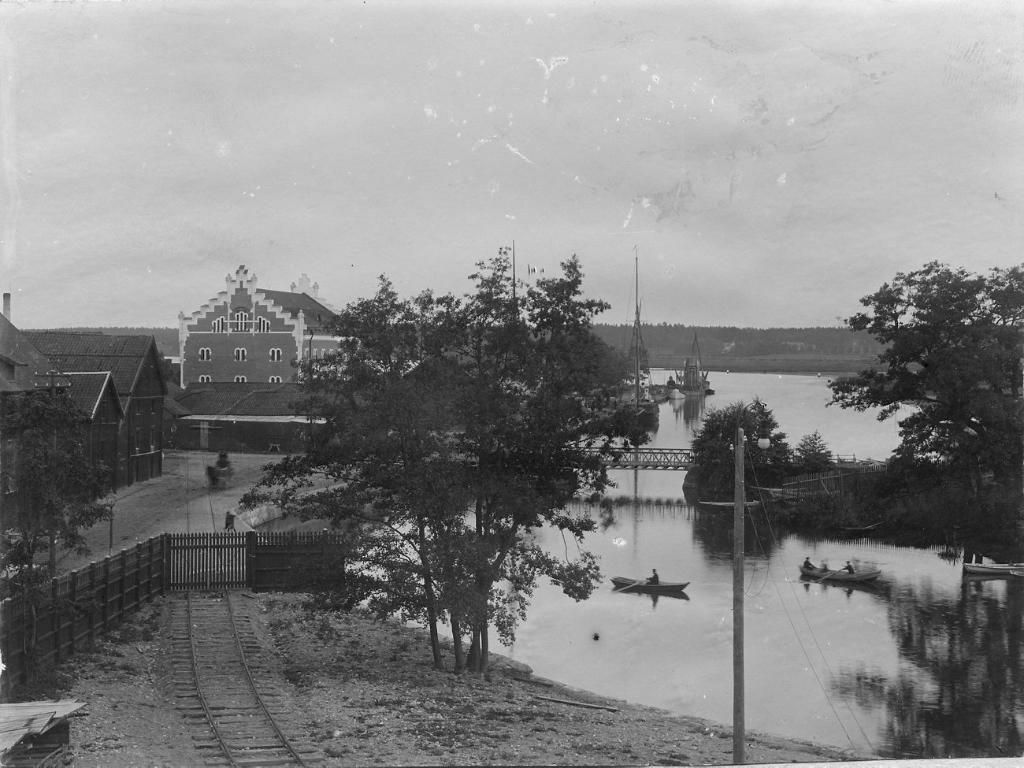What is the color scheme of the image? The image is black and white. What type of structures can be seen in the image? There are buildings in the image. What natural elements are present in the image? There are trees in the image. What man-made feature is visible in the image? There is a railway track in the image. What architectural element can be seen in the image? There is a railing in the image. What mode of transportation is depicted in the image? There are boats on a river in the image. What type of infrastructure is present in the image? There is a bridge in the image. What part of the natural environment is visible in the background of the image? The sky is visible in the background of the image. Where is the scarecrow located in the image? There is no scarecrow present in the image. What type of fruit is hanging from the trees in the image? The image is black and white, so it is not possible to determine the type of fruit hanging from the trees. 